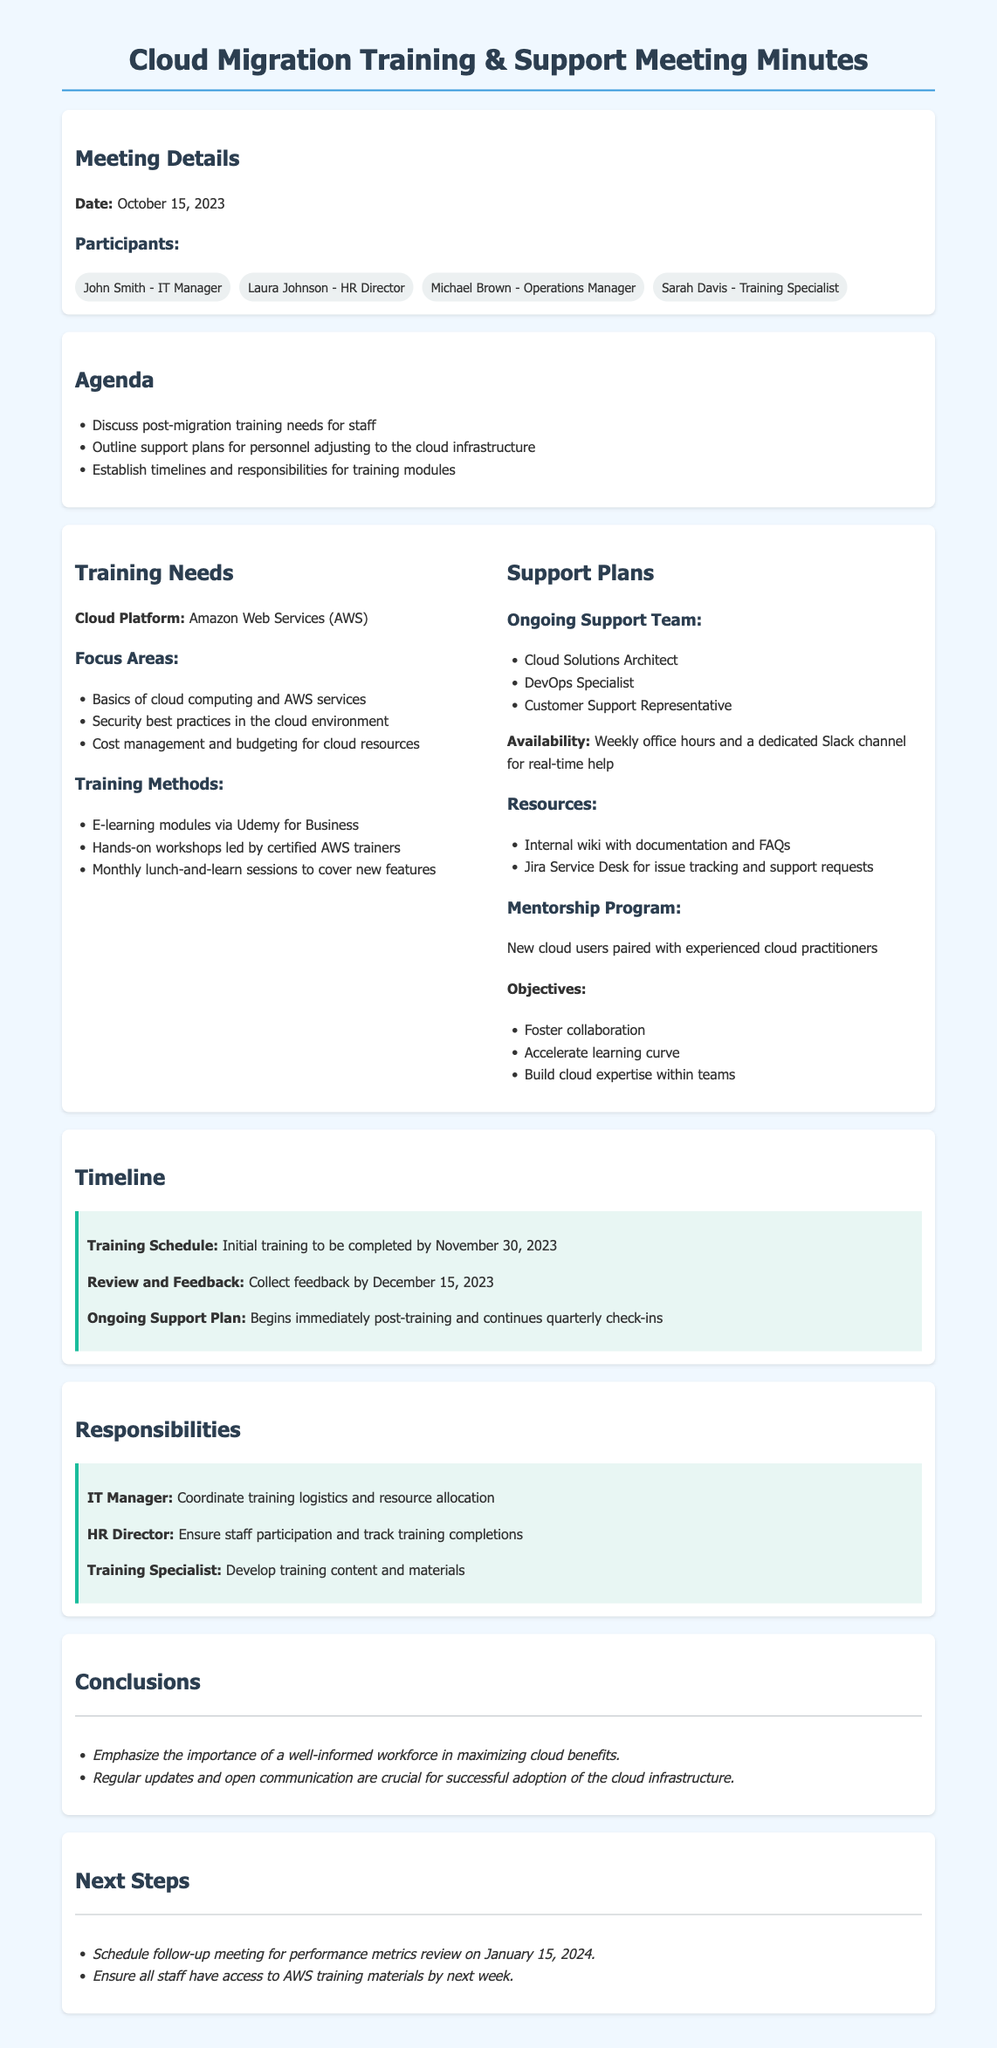what is the date of the meeting? The date of the meeting is explicitly stated in the document.
Answer: October 15, 2023 who is the IT Manager? The participant list includes names and titles, from which the IT Manager can be identified.
Answer: John Smith what cloud platform is being used? The document clearly mentions the platform that staff will train on.
Answer: Amazon Web Services (AWS) what is the deadline for initial training completion? The timeline specifies when the initial training should be completed by.
Answer: November 30, 2023 who is responsible for coordinating training logistics? The responsibilities section identifies who has this specific duty.
Answer: IT Manager what resources are provided for support? The support plans outline specific resources available for staff assistance.
Answer: Internal wiki with documentation and FAQs how many months will the ongoing support plan continue? The timeline indicates the frequency of the check-ins for the support plan.
Answer: Quarterly what is the objective of the mentorship program? The document lists specific goals outlined for this program.
Answer: Foster collaboration when is the follow-up meeting scheduled? The next steps section includes details about a future meeting.
Answer: January 15, 2024 